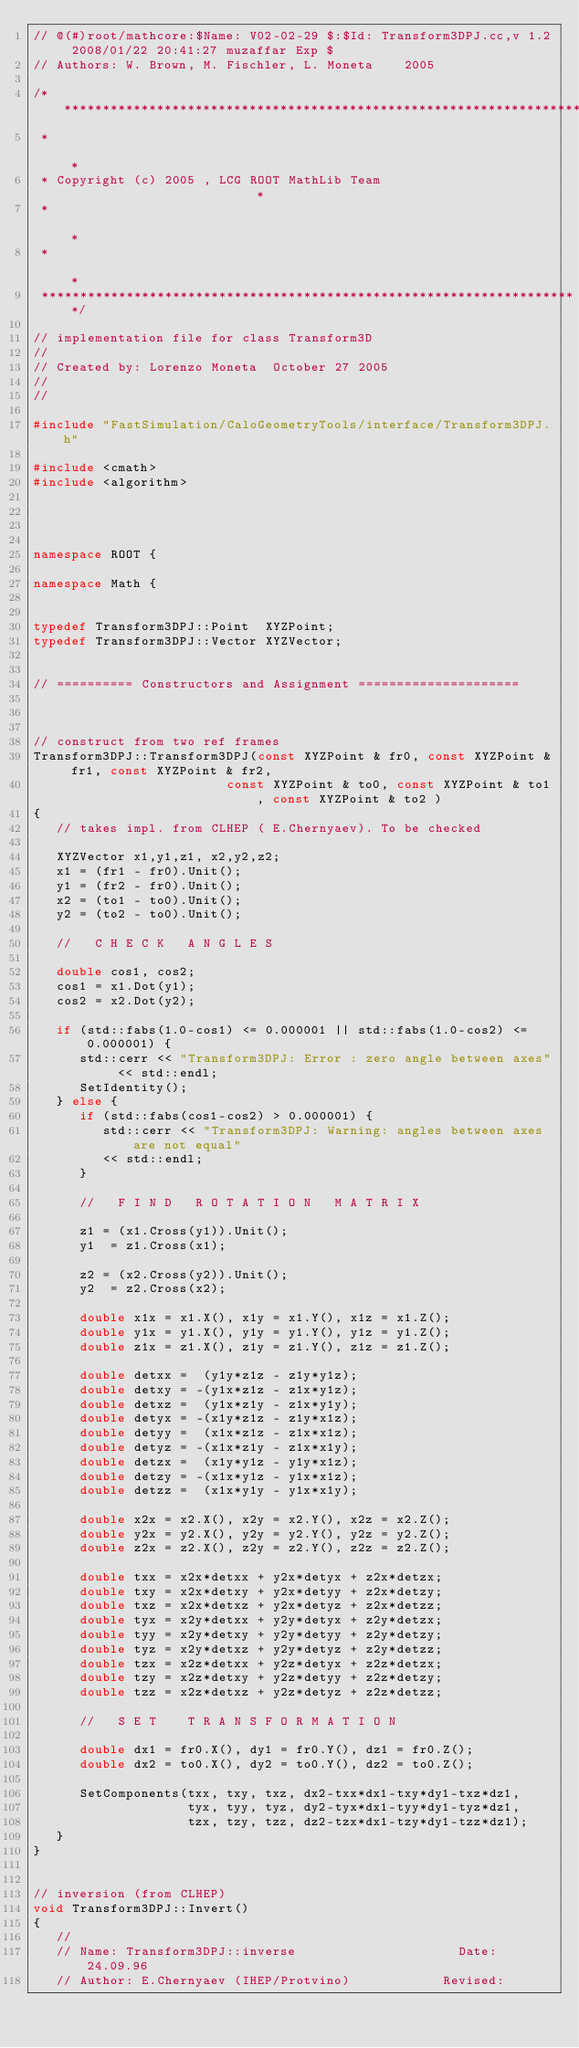Convert code to text. <code><loc_0><loc_0><loc_500><loc_500><_C++_>// @(#)root/mathcore:$Name: V02-02-29 $:$Id: Transform3DPJ.cc,v 1.2 2008/01/22 20:41:27 muzaffar Exp $
// Authors: W. Brown, M. Fischler, L. Moneta    2005

/**********************************************************************
 *                                                                    *
 * Copyright (c) 2005 , LCG ROOT MathLib Team                         *
 *                                                                    *
 *                                                                    *
 **********************************************************************/

// implementation file for class Transform3D
//
// Created by: Lorenzo Moneta  October 27 2005
//
//

#include "FastSimulation/CaloGeometryTools/interface/Transform3DPJ.h"

#include <cmath>
#include <algorithm>




namespace ROOT {

namespace Math {


typedef Transform3DPJ::Point  XYZPoint; 
typedef Transform3DPJ::Vector XYZVector; 


// ========== Constructors and Assignment =====================



// construct from two ref frames
Transform3DPJ::Transform3DPJ(const XYZPoint & fr0, const XYZPoint & fr1, const XYZPoint & fr2,
                         const XYZPoint & to0, const XYZPoint & to1, const XYZPoint & to2 )
{
   // takes impl. from CLHEP ( E.Chernyaev). To be checked
   
   XYZVector x1,y1,z1, x2,y2,z2;
   x1 = (fr1 - fr0).Unit();
   y1 = (fr2 - fr0).Unit();
   x2 = (to1 - to0).Unit();
   y2 = (to2 - to0).Unit();
   
   //   C H E C K   A N G L E S
   
   double cos1, cos2;
   cos1 = x1.Dot(y1);
   cos2 = x2.Dot(y2);
   
   if (std::fabs(1.0-cos1) <= 0.000001 || std::fabs(1.0-cos2) <= 0.000001) {
      std::cerr << "Transform3DPJ: Error : zero angle between axes" << std::endl;
      SetIdentity();
   } else {
      if (std::fabs(cos1-cos2) > 0.000001) {
         std::cerr << "Transform3DPJ: Warning: angles between axes are not equal"
         << std::endl;
      }
      
      //   F I N D   R O T A T I O N   M A T R I X
      
      z1 = (x1.Cross(y1)).Unit();
      y1  = z1.Cross(x1);
      
      z2 = (x2.Cross(y2)).Unit();
      y2  = z2.Cross(x2);

      double x1x = x1.X(), x1y = x1.Y(), x1z = x1.Z();
      double y1x = y1.X(), y1y = y1.Y(), y1z = y1.Z();
      double z1x = z1.X(), z1y = z1.Y(), z1z = z1.Z();
      
      double detxx =  (y1y*z1z - z1y*y1z);
      double detxy = -(y1x*z1z - z1x*y1z);
      double detxz =  (y1x*z1y - z1x*y1y);
      double detyx = -(x1y*z1z - z1y*x1z);
      double detyy =  (x1x*z1z - z1x*x1z);
      double detyz = -(x1x*z1y - z1x*x1y);
      double detzx =  (x1y*y1z - y1y*x1z);
      double detzy = -(x1x*y1z - y1x*x1z);
      double detzz =  (x1x*y1y - y1x*x1y);

      double x2x = x2.X(), x2y = x2.Y(), x2z = x2.Z();
      double y2x = y2.X(), y2y = y2.Y(), y2z = y2.Z();
      double z2x = z2.X(), z2y = z2.Y(), z2z = z2.Z();

      double txx = x2x*detxx + y2x*detyx + z2x*detzx;
      double txy = x2x*detxy + y2x*detyy + z2x*detzy;
      double txz = x2x*detxz + y2x*detyz + z2x*detzz;
      double tyx = x2y*detxx + y2y*detyx + z2y*detzx;
      double tyy = x2y*detxy + y2y*detyy + z2y*detzy;
      double tyz = x2y*detxz + y2y*detyz + z2y*detzz;
      double tzx = x2z*detxx + y2z*detyx + z2z*detzx;
      double tzy = x2z*detxy + y2z*detyy + z2z*detzy;
      double tzz = x2z*detxz + y2z*detyz + z2z*detzz;
      
      //   S E T    T R A N S F O R M A T I O N
      
      double dx1 = fr0.X(), dy1 = fr0.Y(), dz1 = fr0.Z();
      double dx2 = to0.X(), dy2 = to0.Y(), dz2 = to0.Z();
      
      SetComponents(txx, txy, txz, dx2-txx*dx1-txy*dy1-txz*dz1,
                    tyx, tyy, tyz, dy2-tyx*dx1-tyy*dy1-tyz*dz1,
                    tzx, tzy, tzz, dz2-tzx*dx1-tzy*dy1-tzz*dz1);
   }
}


// inversion (from CLHEP)
void Transform3DPJ::Invert()
{
   //
   // Name: Transform3DPJ::inverse                     Date:    24.09.96
   // Author: E.Chernyaev (IHEP/Protvino)            Revised:</code> 